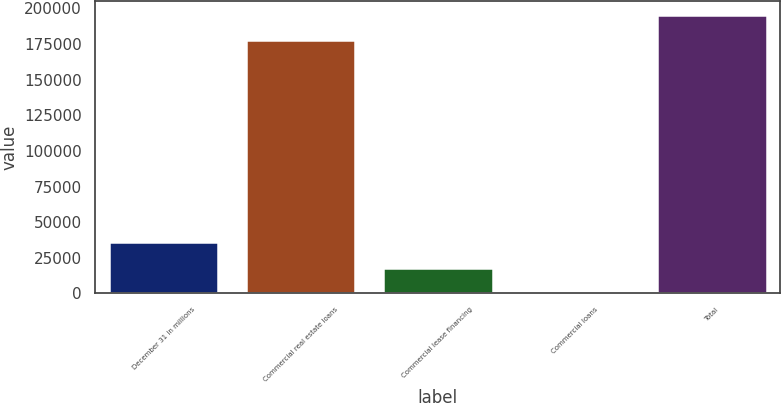Convert chart to OTSL. <chart><loc_0><loc_0><loc_500><loc_500><bar_chart><fcel>December 31 in millions<fcel>Commercial real estate loans<fcel>Commercial lease financing<fcel>Commercial loans<fcel>Total<nl><fcel>36016.6<fcel>177731<fcel>18171.8<fcel>327<fcel>195576<nl></chart> 